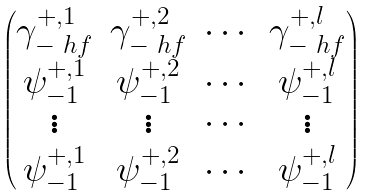<formula> <loc_0><loc_0><loc_500><loc_500>\begin{pmatrix} \gamma _ { - \ h f } ^ { + , 1 } & \gamma _ { - \ h f } ^ { + , 2 } & \cdots & \gamma _ { - \ h f } ^ { + , l } \\ \psi _ { - 1 } ^ { + , 1 } & \psi _ { - 1 } ^ { + , 2 } & \cdots & \psi _ { - 1 } ^ { + , l } \\ \vdots & \vdots & \cdots & \vdots \\ \psi _ { - 1 } ^ { + , 1 } & \psi _ { - 1 } ^ { + , 2 } & \cdots & \psi _ { - 1 } ^ { + , l } \\ \end{pmatrix}</formula> 